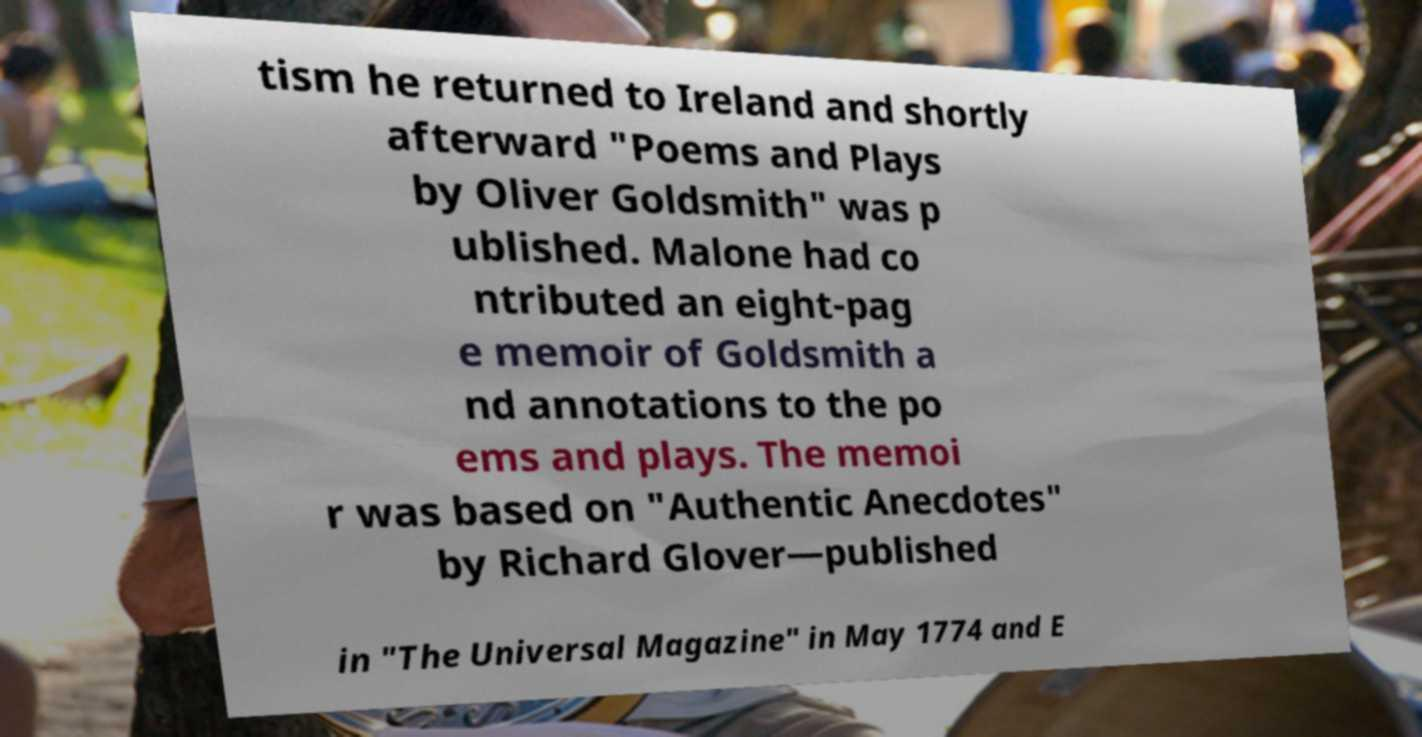There's text embedded in this image that I need extracted. Can you transcribe it verbatim? tism he returned to Ireland and shortly afterward "Poems and Plays by Oliver Goldsmith" was p ublished. Malone had co ntributed an eight-pag e memoir of Goldsmith a nd annotations to the po ems and plays. The memoi r was based on "Authentic Anecdotes" by Richard Glover—published in "The Universal Magazine" in May 1774 and E 